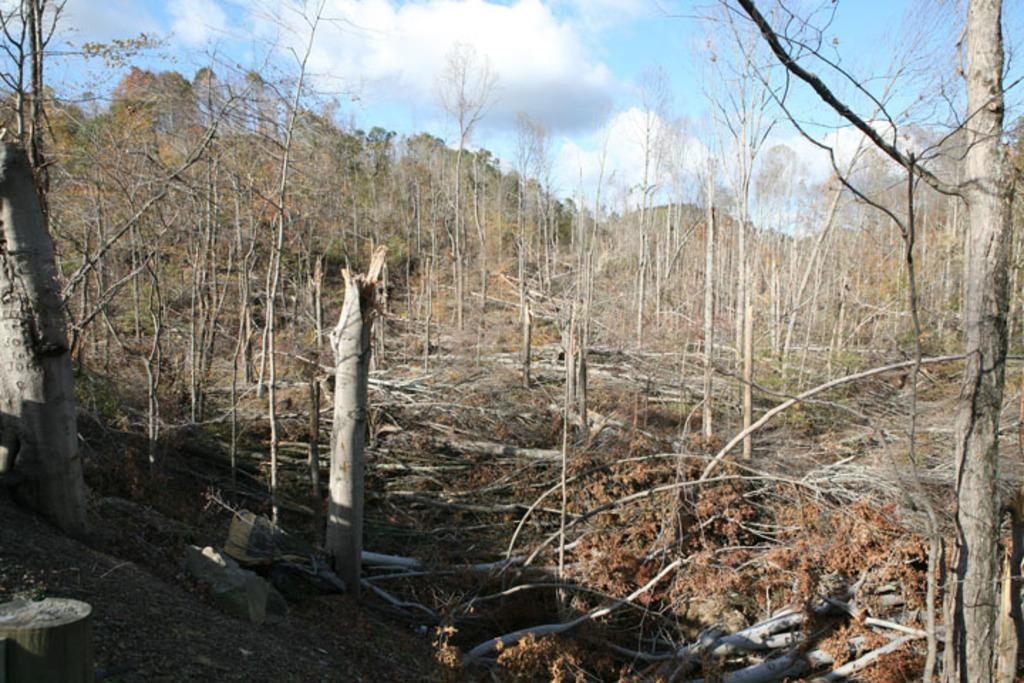What can be seen in the middle of the image? There are trees in the middle of the image. What is visible at the top of the image? The sky is visible at the top of the image. Can you describe the sky in the image? The sky appears to be cloudy in the image. What grade did the trees receive in the image? There is no grading system or evaluation present in the image, so it is not possible to determine a grade for the trees. 